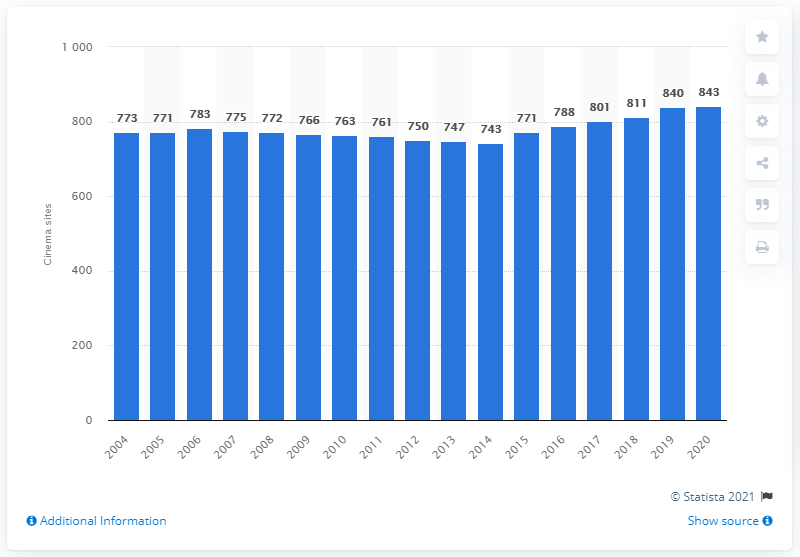Specify some key components in this picture. In 2020, there were 843 cinemas in the United Kingdom. 